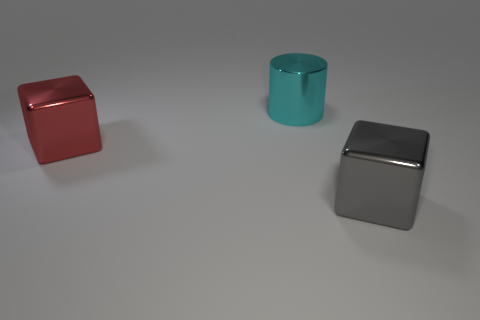Add 1 large red spheres. How many objects exist? 4 Subtract all red blocks. How many blocks are left? 1 Subtract all yellow cylinders. How many red cubes are left? 1 Add 2 big cyan objects. How many big cyan objects are left? 3 Add 2 gray metal cubes. How many gray metal cubes exist? 3 Subtract 0 blue cubes. How many objects are left? 3 Subtract all cylinders. How many objects are left? 2 Subtract 1 blocks. How many blocks are left? 1 Subtract all cyan blocks. Subtract all red cylinders. How many blocks are left? 2 Subtract all big objects. Subtract all large spheres. How many objects are left? 0 